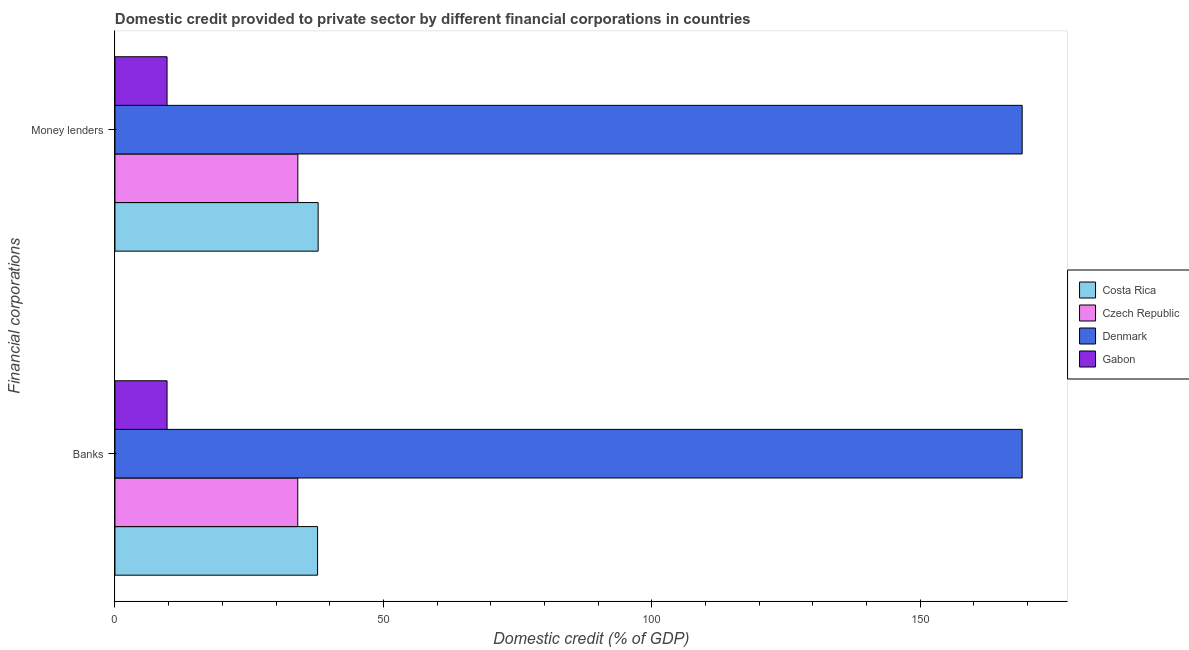How many different coloured bars are there?
Your response must be concise. 4. Are the number of bars per tick equal to the number of legend labels?
Your answer should be very brief. Yes. Are the number of bars on each tick of the Y-axis equal?
Your answer should be very brief. Yes. How many bars are there on the 2nd tick from the top?
Give a very brief answer. 4. What is the label of the 2nd group of bars from the top?
Give a very brief answer. Banks. What is the domestic credit provided by money lenders in Costa Rica?
Offer a very short reply. 37.85. Across all countries, what is the maximum domestic credit provided by money lenders?
Make the answer very short. 169. Across all countries, what is the minimum domestic credit provided by money lenders?
Your response must be concise. 9.71. In which country was the domestic credit provided by banks maximum?
Offer a very short reply. Denmark. In which country was the domestic credit provided by money lenders minimum?
Give a very brief answer. Gabon. What is the total domestic credit provided by money lenders in the graph?
Provide a succinct answer. 250.63. What is the difference between the domestic credit provided by money lenders in Denmark and that in Gabon?
Offer a very short reply. 159.29. What is the difference between the domestic credit provided by banks in Costa Rica and the domestic credit provided by money lenders in Czech Republic?
Offer a terse response. 3.68. What is the average domestic credit provided by banks per country?
Provide a short and direct response. 62.63. What is the difference between the domestic credit provided by money lenders and domestic credit provided by banks in Czech Republic?
Provide a short and direct response. 0.01. In how many countries, is the domestic credit provided by banks greater than 140 %?
Your response must be concise. 1. What is the ratio of the domestic credit provided by money lenders in Czech Republic to that in Denmark?
Provide a succinct answer. 0.2. Is the domestic credit provided by money lenders in Denmark less than that in Costa Rica?
Provide a succinct answer. No. What does the 3rd bar from the bottom in Money lenders represents?
Make the answer very short. Denmark. Are all the bars in the graph horizontal?
Ensure brevity in your answer.  Yes. How many countries are there in the graph?
Give a very brief answer. 4. Does the graph contain grids?
Provide a short and direct response. No. How many legend labels are there?
Give a very brief answer. 4. What is the title of the graph?
Your response must be concise. Domestic credit provided to private sector by different financial corporations in countries. What is the label or title of the X-axis?
Make the answer very short. Domestic credit (% of GDP). What is the label or title of the Y-axis?
Offer a terse response. Financial corporations. What is the Domestic credit (% of GDP) of Costa Rica in Banks?
Your response must be concise. 37.75. What is the Domestic credit (% of GDP) in Czech Republic in Banks?
Provide a succinct answer. 34.06. What is the Domestic credit (% of GDP) in Denmark in Banks?
Provide a short and direct response. 169. What is the Domestic credit (% of GDP) in Gabon in Banks?
Provide a succinct answer. 9.71. What is the Domestic credit (% of GDP) of Costa Rica in Money lenders?
Provide a short and direct response. 37.85. What is the Domestic credit (% of GDP) in Czech Republic in Money lenders?
Keep it short and to the point. 34.07. What is the Domestic credit (% of GDP) of Denmark in Money lenders?
Make the answer very short. 169. What is the Domestic credit (% of GDP) in Gabon in Money lenders?
Your response must be concise. 9.71. Across all Financial corporations, what is the maximum Domestic credit (% of GDP) of Costa Rica?
Offer a terse response. 37.85. Across all Financial corporations, what is the maximum Domestic credit (% of GDP) of Czech Republic?
Make the answer very short. 34.07. Across all Financial corporations, what is the maximum Domestic credit (% of GDP) in Denmark?
Give a very brief answer. 169. Across all Financial corporations, what is the maximum Domestic credit (% of GDP) of Gabon?
Your response must be concise. 9.71. Across all Financial corporations, what is the minimum Domestic credit (% of GDP) in Costa Rica?
Ensure brevity in your answer.  37.75. Across all Financial corporations, what is the minimum Domestic credit (% of GDP) of Czech Republic?
Ensure brevity in your answer.  34.06. Across all Financial corporations, what is the minimum Domestic credit (% of GDP) in Denmark?
Provide a short and direct response. 169. Across all Financial corporations, what is the minimum Domestic credit (% of GDP) in Gabon?
Your answer should be very brief. 9.71. What is the total Domestic credit (% of GDP) in Costa Rica in the graph?
Provide a succinct answer. 75.6. What is the total Domestic credit (% of GDP) in Czech Republic in the graph?
Keep it short and to the point. 68.13. What is the total Domestic credit (% of GDP) in Denmark in the graph?
Your answer should be compact. 338. What is the total Domestic credit (% of GDP) in Gabon in the graph?
Your answer should be very brief. 19.42. What is the difference between the Domestic credit (% of GDP) of Costa Rica in Banks and that in Money lenders?
Your response must be concise. -0.11. What is the difference between the Domestic credit (% of GDP) of Czech Republic in Banks and that in Money lenders?
Give a very brief answer. -0.01. What is the difference between the Domestic credit (% of GDP) of Denmark in Banks and that in Money lenders?
Offer a terse response. -0. What is the difference between the Domestic credit (% of GDP) of Costa Rica in Banks and the Domestic credit (% of GDP) of Czech Republic in Money lenders?
Give a very brief answer. 3.68. What is the difference between the Domestic credit (% of GDP) in Costa Rica in Banks and the Domestic credit (% of GDP) in Denmark in Money lenders?
Offer a terse response. -131.25. What is the difference between the Domestic credit (% of GDP) in Costa Rica in Banks and the Domestic credit (% of GDP) in Gabon in Money lenders?
Make the answer very short. 28.04. What is the difference between the Domestic credit (% of GDP) in Czech Republic in Banks and the Domestic credit (% of GDP) in Denmark in Money lenders?
Provide a short and direct response. -134.94. What is the difference between the Domestic credit (% of GDP) in Czech Republic in Banks and the Domestic credit (% of GDP) in Gabon in Money lenders?
Give a very brief answer. 24.35. What is the difference between the Domestic credit (% of GDP) of Denmark in Banks and the Domestic credit (% of GDP) of Gabon in Money lenders?
Offer a very short reply. 159.29. What is the average Domestic credit (% of GDP) in Costa Rica per Financial corporations?
Keep it short and to the point. 37.8. What is the average Domestic credit (% of GDP) in Czech Republic per Financial corporations?
Give a very brief answer. 34.06. What is the average Domestic credit (% of GDP) of Denmark per Financial corporations?
Your response must be concise. 169. What is the average Domestic credit (% of GDP) in Gabon per Financial corporations?
Ensure brevity in your answer.  9.71. What is the difference between the Domestic credit (% of GDP) in Costa Rica and Domestic credit (% of GDP) in Czech Republic in Banks?
Provide a succinct answer. 3.69. What is the difference between the Domestic credit (% of GDP) of Costa Rica and Domestic credit (% of GDP) of Denmark in Banks?
Provide a succinct answer. -131.25. What is the difference between the Domestic credit (% of GDP) of Costa Rica and Domestic credit (% of GDP) of Gabon in Banks?
Offer a very short reply. 28.04. What is the difference between the Domestic credit (% of GDP) of Czech Republic and Domestic credit (% of GDP) of Denmark in Banks?
Provide a succinct answer. -134.94. What is the difference between the Domestic credit (% of GDP) of Czech Republic and Domestic credit (% of GDP) of Gabon in Banks?
Your answer should be compact. 24.35. What is the difference between the Domestic credit (% of GDP) in Denmark and Domestic credit (% of GDP) in Gabon in Banks?
Your answer should be very brief. 159.29. What is the difference between the Domestic credit (% of GDP) of Costa Rica and Domestic credit (% of GDP) of Czech Republic in Money lenders?
Your answer should be compact. 3.78. What is the difference between the Domestic credit (% of GDP) of Costa Rica and Domestic credit (% of GDP) of Denmark in Money lenders?
Provide a succinct answer. -131.15. What is the difference between the Domestic credit (% of GDP) of Costa Rica and Domestic credit (% of GDP) of Gabon in Money lenders?
Provide a succinct answer. 28.14. What is the difference between the Domestic credit (% of GDP) of Czech Republic and Domestic credit (% of GDP) of Denmark in Money lenders?
Provide a succinct answer. -134.93. What is the difference between the Domestic credit (% of GDP) in Czech Republic and Domestic credit (% of GDP) in Gabon in Money lenders?
Your response must be concise. 24.36. What is the difference between the Domestic credit (% of GDP) of Denmark and Domestic credit (% of GDP) of Gabon in Money lenders?
Your response must be concise. 159.29. What is the difference between the highest and the second highest Domestic credit (% of GDP) of Costa Rica?
Your answer should be compact. 0.11. What is the difference between the highest and the second highest Domestic credit (% of GDP) in Czech Republic?
Your response must be concise. 0.01. What is the difference between the highest and the second highest Domestic credit (% of GDP) of Gabon?
Your answer should be very brief. 0. What is the difference between the highest and the lowest Domestic credit (% of GDP) of Costa Rica?
Offer a terse response. 0.11. What is the difference between the highest and the lowest Domestic credit (% of GDP) of Czech Republic?
Give a very brief answer. 0.01. What is the difference between the highest and the lowest Domestic credit (% of GDP) in Denmark?
Ensure brevity in your answer.  0. 